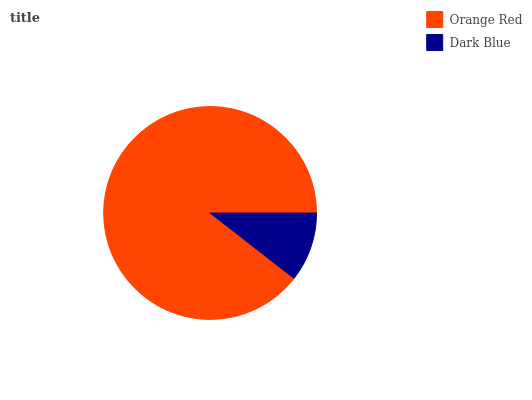Is Dark Blue the minimum?
Answer yes or no. Yes. Is Orange Red the maximum?
Answer yes or no. Yes. Is Dark Blue the maximum?
Answer yes or no. No. Is Orange Red greater than Dark Blue?
Answer yes or no. Yes. Is Dark Blue less than Orange Red?
Answer yes or no. Yes. Is Dark Blue greater than Orange Red?
Answer yes or no. No. Is Orange Red less than Dark Blue?
Answer yes or no. No. Is Orange Red the high median?
Answer yes or no. Yes. Is Dark Blue the low median?
Answer yes or no. Yes. Is Dark Blue the high median?
Answer yes or no. No. Is Orange Red the low median?
Answer yes or no. No. 